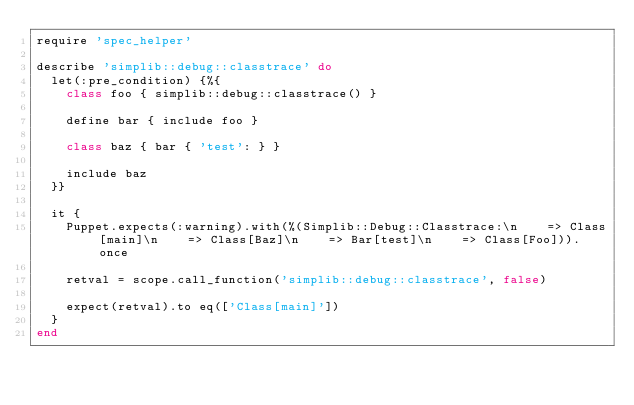Convert code to text. <code><loc_0><loc_0><loc_500><loc_500><_Ruby_>require 'spec_helper'

describe 'simplib::debug::classtrace' do
  let(:pre_condition) {%{
    class foo { simplib::debug::classtrace() }

    define bar { include foo }

    class baz { bar { 'test': } }

    include baz
  }}

  it {
    Puppet.expects(:warning).with(%(Simplib::Debug::Classtrace:\n    => Class[main]\n    => Class[Baz]\n    => Bar[test]\n    => Class[Foo])).once

    retval = scope.call_function('simplib::debug::classtrace', false)

    expect(retval).to eq(['Class[main]'])
  }
end
</code> 